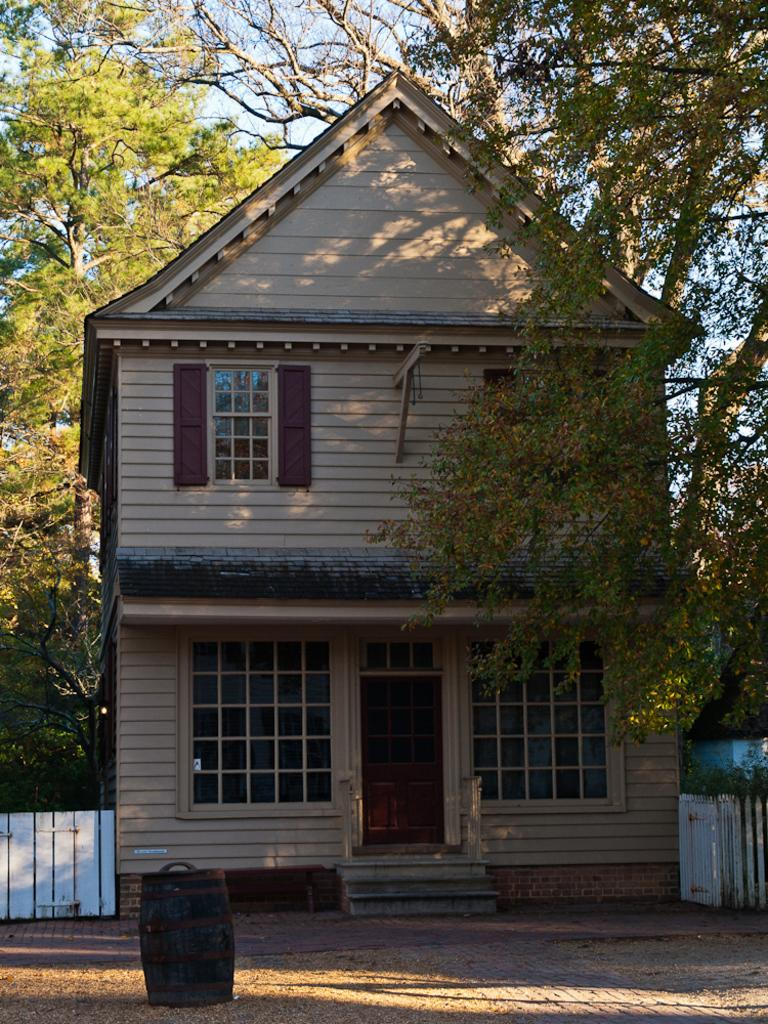What type of structure is visible in the picture? There is a house in the picture. What natural elements can be seen in the picture? There are trees in the picture. What man-made object is present in the picture? There is a fence in the picture. What object is on the ground in the picture? There is a barrel on the ground in the picture. Is there a person walking in the rain near the house in the picture? There is no person or rain visible in the picture; it only shows a house, trees, a fence, and a barrel on the ground. 